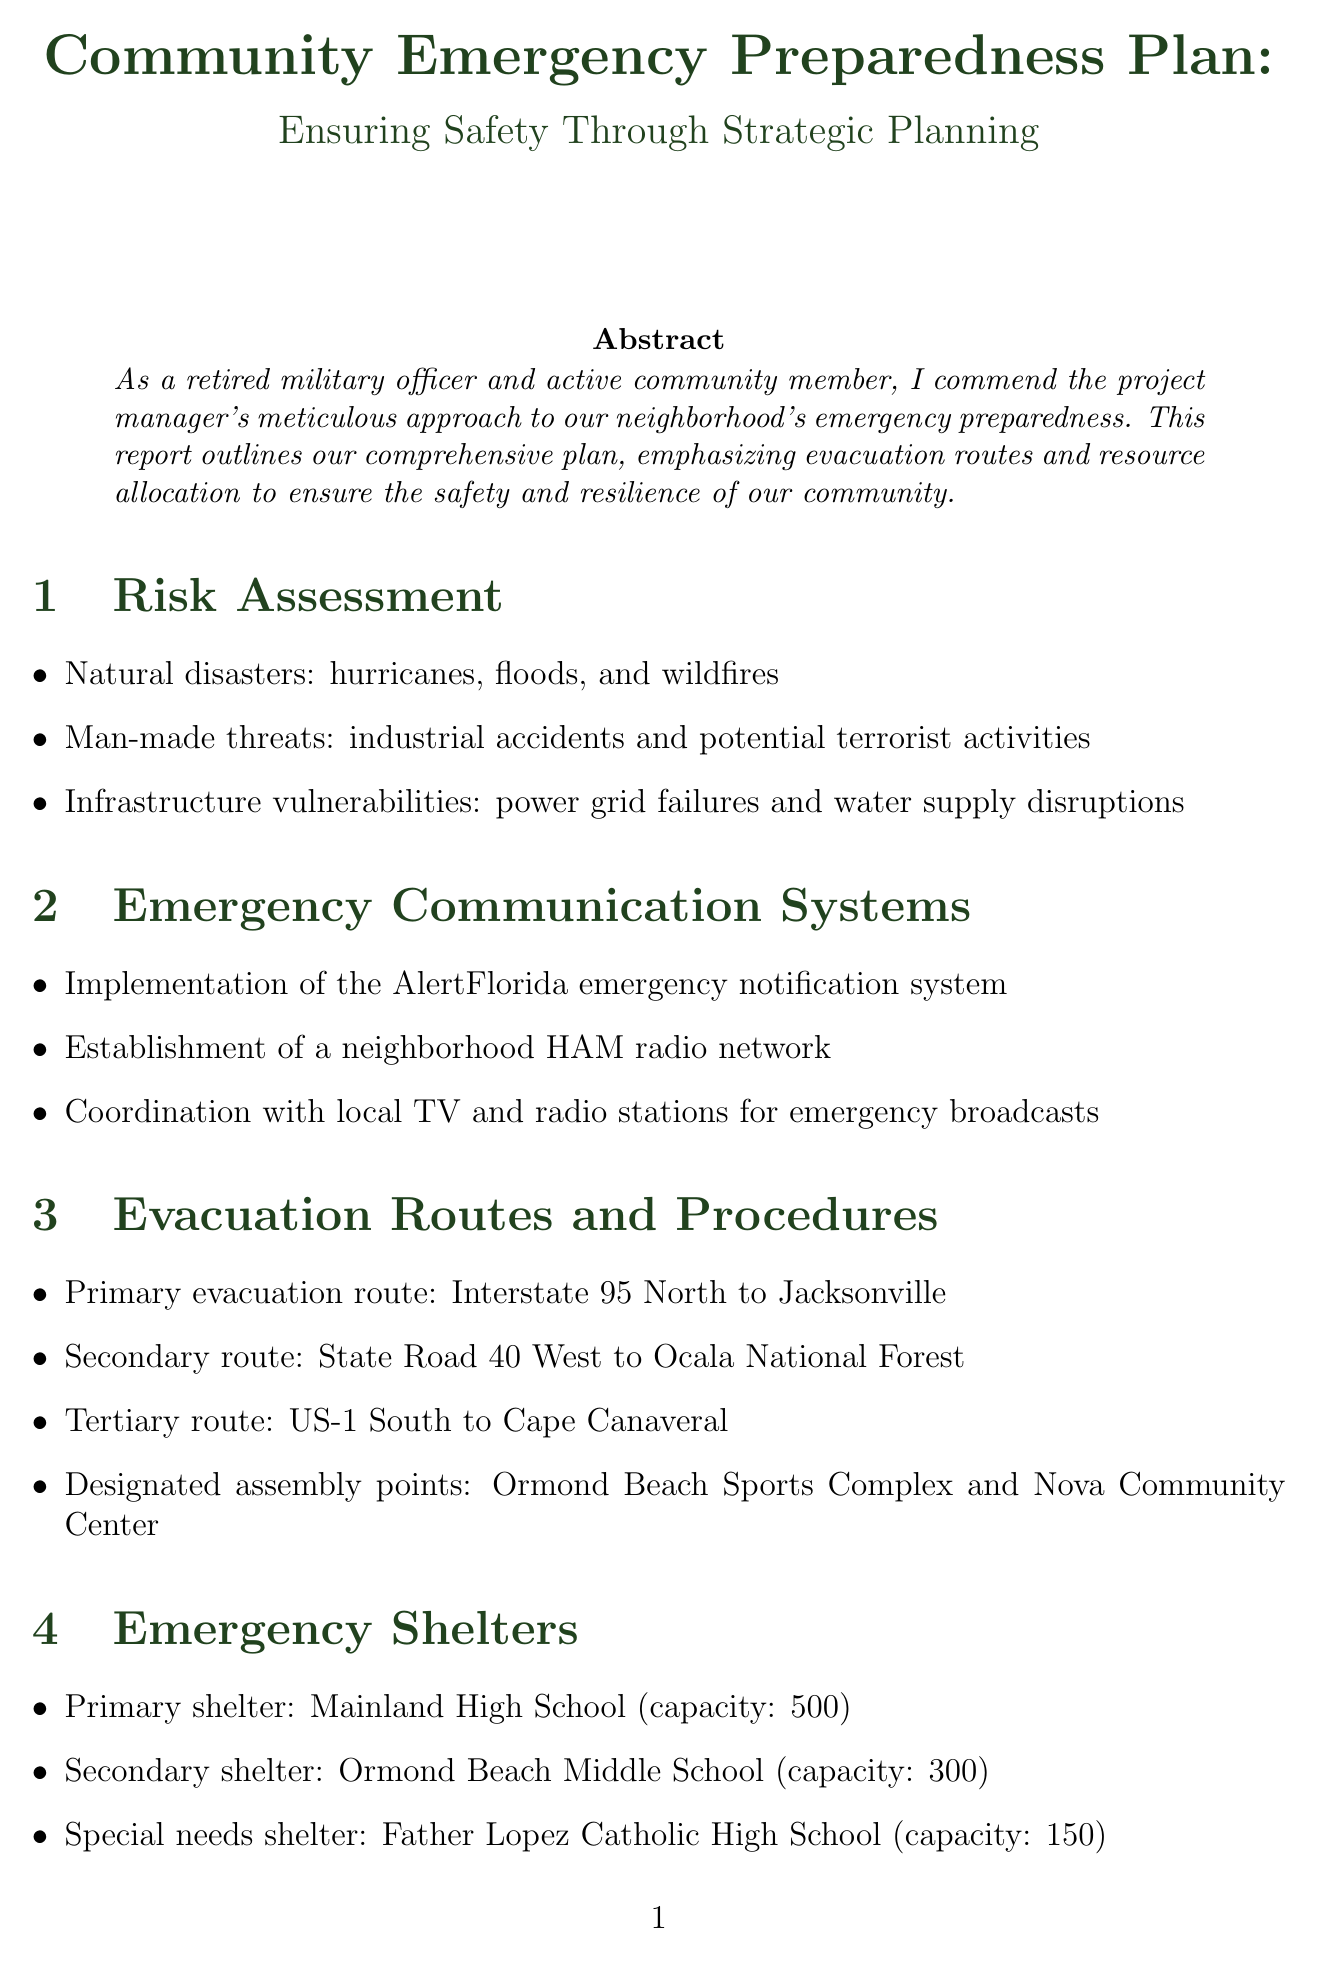what is the primary evacuation route? The primary evacuation route is specified in the document as Interstate 95 North to Jacksonville.
Answer: Interstate 95 North to Jacksonville what is the capacity of the primary shelter? The primary shelter, Mainland High School, has a capacity of 500.
Answer: 500 which emergency communication system is implemented? The document mentions the implementation of the AlertFlorida emergency notification system as part of the emergency communication systems.
Answer: AlertFlorida what are the designated assembly points? The designated assembly points listed in the report are Ormond Beach Sports Complex and Nova Community Center.
Answer: Ormond Beach Sports Complex and Nova Community Center how often are tabletop exercises conducted for emergency response teams? The document states that quarterly tabletop exercises are conducted for emergency response teams.
Answer: Quarterly what special needs shelter is mentioned? The document mentions Father Lopez Catholic High School as the special needs shelter with a capacity of 150.
Answer: Father Lopez Catholic High School how many community-wide emergency preparedness drills are held annually? The report specifies that there is an annual community-wide emergency preparedness drill.
Answer: Annual who is responsible for fire suppression and rescue operations? The Ormond Beach Fire Department is identified in the document as responsible for fire suppression and rescue operations.
Answer: Ormond Beach Fire Department 